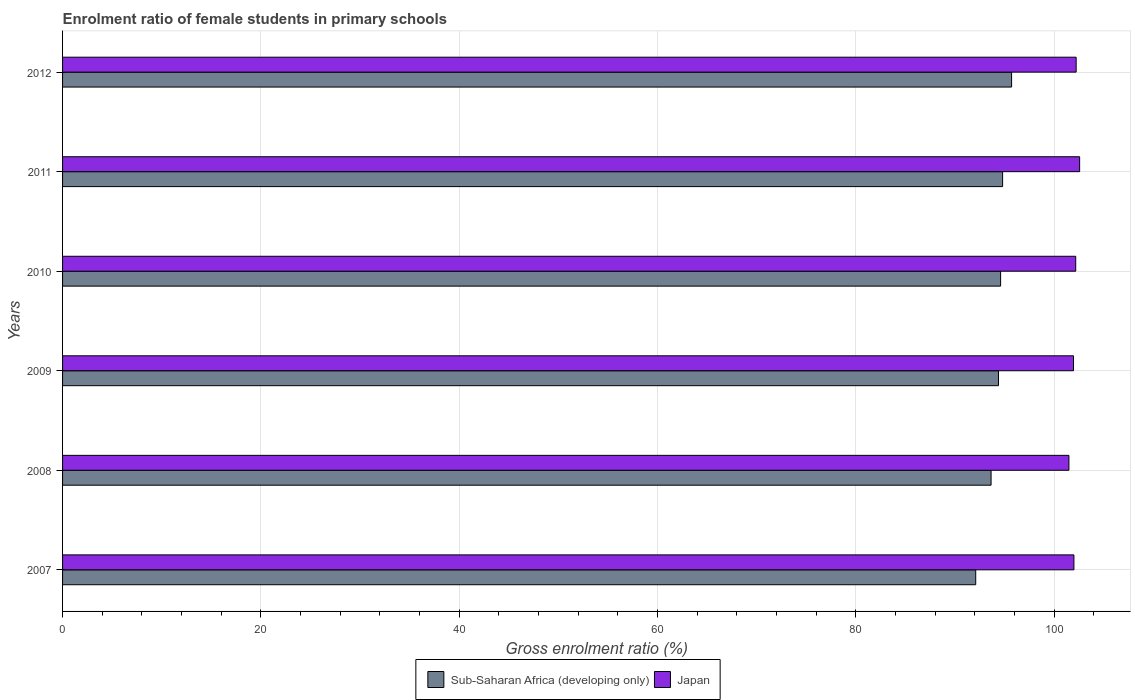How many different coloured bars are there?
Offer a very short reply. 2. How many groups of bars are there?
Keep it short and to the point. 6. How many bars are there on the 2nd tick from the top?
Keep it short and to the point. 2. What is the enrolment ratio of female students in primary schools in Japan in 2008?
Your answer should be compact. 101.48. Across all years, what is the maximum enrolment ratio of female students in primary schools in Japan?
Ensure brevity in your answer.  102.56. Across all years, what is the minimum enrolment ratio of female students in primary schools in Sub-Saharan Africa (developing only)?
Your response must be concise. 92.09. What is the total enrolment ratio of female students in primary schools in Japan in the graph?
Offer a very short reply. 612.36. What is the difference between the enrolment ratio of female students in primary schools in Sub-Saharan Africa (developing only) in 2008 and that in 2011?
Keep it short and to the point. -1.16. What is the difference between the enrolment ratio of female students in primary schools in Sub-Saharan Africa (developing only) in 2010 and the enrolment ratio of female students in primary schools in Japan in 2007?
Your response must be concise. -7.39. What is the average enrolment ratio of female students in primary schools in Japan per year?
Your answer should be very brief. 102.06. In the year 2009, what is the difference between the enrolment ratio of female students in primary schools in Sub-Saharan Africa (developing only) and enrolment ratio of female students in primary schools in Japan?
Your answer should be very brief. -7.56. What is the ratio of the enrolment ratio of female students in primary schools in Sub-Saharan Africa (developing only) in 2009 to that in 2012?
Your answer should be compact. 0.99. What is the difference between the highest and the second highest enrolment ratio of female students in primary schools in Sub-Saharan Africa (developing only)?
Make the answer very short. 0.91. What is the difference between the highest and the lowest enrolment ratio of female students in primary schools in Sub-Saharan Africa (developing only)?
Make the answer very short. 3.62. In how many years, is the enrolment ratio of female students in primary schools in Sub-Saharan Africa (developing only) greater than the average enrolment ratio of female students in primary schools in Sub-Saharan Africa (developing only) taken over all years?
Offer a very short reply. 4. Is the sum of the enrolment ratio of female students in primary schools in Japan in 2008 and 2012 greater than the maximum enrolment ratio of female students in primary schools in Sub-Saharan Africa (developing only) across all years?
Offer a very short reply. Yes. What does the 1st bar from the bottom in 2010 represents?
Give a very brief answer. Sub-Saharan Africa (developing only). How many bars are there?
Give a very brief answer. 12. Does the graph contain grids?
Your response must be concise. Yes. How many legend labels are there?
Offer a very short reply. 2. What is the title of the graph?
Your answer should be compact. Enrolment ratio of female students in primary schools. Does "Latvia" appear as one of the legend labels in the graph?
Keep it short and to the point. No. What is the label or title of the X-axis?
Offer a terse response. Gross enrolment ratio (%). What is the Gross enrolment ratio (%) in Sub-Saharan Africa (developing only) in 2007?
Your answer should be very brief. 92.09. What is the Gross enrolment ratio (%) of Japan in 2007?
Give a very brief answer. 101.99. What is the Gross enrolment ratio (%) of Sub-Saharan Africa (developing only) in 2008?
Provide a succinct answer. 93.63. What is the Gross enrolment ratio (%) in Japan in 2008?
Your response must be concise. 101.48. What is the Gross enrolment ratio (%) of Sub-Saharan Africa (developing only) in 2009?
Ensure brevity in your answer.  94.38. What is the Gross enrolment ratio (%) of Japan in 2009?
Offer a very short reply. 101.94. What is the Gross enrolment ratio (%) of Sub-Saharan Africa (developing only) in 2010?
Make the answer very short. 94.59. What is the Gross enrolment ratio (%) of Japan in 2010?
Give a very brief answer. 102.17. What is the Gross enrolment ratio (%) of Sub-Saharan Africa (developing only) in 2011?
Offer a very short reply. 94.8. What is the Gross enrolment ratio (%) in Japan in 2011?
Keep it short and to the point. 102.56. What is the Gross enrolment ratio (%) in Sub-Saharan Africa (developing only) in 2012?
Provide a succinct answer. 95.7. What is the Gross enrolment ratio (%) of Japan in 2012?
Give a very brief answer. 102.21. Across all years, what is the maximum Gross enrolment ratio (%) in Sub-Saharan Africa (developing only)?
Make the answer very short. 95.7. Across all years, what is the maximum Gross enrolment ratio (%) of Japan?
Your answer should be compact. 102.56. Across all years, what is the minimum Gross enrolment ratio (%) in Sub-Saharan Africa (developing only)?
Your answer should be compact. 92.09. Across all years, what is the minimum Gross enrolment ratio (%) in Japan?
Give a very brief answer. 101.48. What is the total Gross enrolment ratio (%) in Sub-Saharan Africa (developing only) in the graph?
Give a very brief answer. 565.19. What is the total Gross enrolment ratio (%) in Japan in the graph?
Offer a very short reply. 612.36. What is the difference between the Gross enrolment ratio (%) of Sub-Saharan Africa (developing only) in 2007 and that in 2008?
Your answer should be compact. -1.55. What is the difference between the Gross enrolment ratio (%) of Japan in 2007 and that in 2008?
Give a very brief answer. 0.5. What is the difference between the Gross enrolment ratio (%) of Sub-Saharan Africa (developing only) in 2007 and that in 2009?
Ensure brevity in your answer.  -2.29. What is the difference between the Gross enrolment ratio (%) in Japan in 2007 and that in 2009?
Make the answer very short. 0.04. What is the difference between the Gross enrolment ratio (%) in Sub-Saharan Africa (developing only) in 2007 and that in 2010?
Offer a terse response. -2.51. What is the difference between the Gross enrolment ratio (%) of Japan in 2007 and that in 2010?
Provide a succinct answer. -0.18. What is the difference between the Gross enrolment ratio (%) of Sub-Saharan Africa (developing only) in 2007 and that in 2011?
Your answer should be very brief. -2.71. What is the difference between the Gross enrolment ratio (%) in Japan in 2007 and that in 2011?
Offer a terse response. -0.58. What is the difference between the Gross enrolment ratio (%) in Sub-Saharan Africa (developing only) in 2007 and that in 2012?
Provide a succinct answer. -3.62. What is the difference between the Gross enrolment ratio (%) of Japan in 2007 and that in 2012?
Give a very brief answer. -0.23. What is the difference between the Gross enrolment ratio (%) in Sub-Saharan Africa (developing only) in 2008 and that in 2009?
Ensure brevity in your answer.  -0.75. What is the difference between the Gross enrolment ratio (%) in Japan in 2008 and that in 2009?
Ensure brevity in your answer.  -0.46. What is the difference between the Gross enrolment ratio (%) of Sub-Saharan Africa (developing only) in 2008 and that in 2010?
Keep it short and to the point. -0.96. What is the difference between the Gross enrolment ratio (%) of Japan in 2008 and that in 2010?
Provide a succinct answer. -0.69. What is the difference between the Gross enrolment ratio (%) of Sub-Saharan Africa (developing only) in 2008 and that in 2011?
Your answer should be compact. -1.16. What is the difference between the Gross enrolment ratio (%) of Japan in 2008 and that in 2011?
Give a very brief answer. -1.08. What is the difference between the Gross enrolment ratio (%) in Sub-Saharan Africa (developing only) in 2008 and that in 2012?
Your answer should be compact. -2.07. What is the difference between the Gross enrolment ratio (%) in Japan in 2008 and that in 2012?
Offer a very short reply. -0.73. What is the difference between the Gross enrolment ratio (%) of Sub-Saharan Africa (developing only) in 2009 and that in 2010?
Offer a very short reply. -0.21. What is the difference between the Gross enrolment ratio (%) of Japan in 2009 and that in 2010?
Ensure brevity in your answer.  -0.22. What is the difference between the Gross enrolment ratio (%) of Sub-Saharan Africa (developing only) in 2009 and that in 2011?
Your answer should be compact. -0.42. What is the difference between the Gross enrolment ratio (%) of Japan in 2009 and that in 2011?
Give a very brief answer. -0.62. What is the difference between the Gross enrolment ratio (%) in Sub-Saharan Africa (developing only) in 2009 and that in 2012?
Give a very brief answer. -1.32. What is the difference between the Gross enrolment ratio (%) in Japan in 2009 and that in 2012?
Offer a terse response. -0.27. What is the difference between the Gross enrolment ratio (%) in Sub-Saharan Africa (developing only) in 2010 and that in 2011?
Give a very brief answer. -0.2. What is the difference between the Gross enrolment ratio (%) of Japan in 2010 and that in 2011?
Keep it short and to the point. -0.4. What is the difference between the Gross enrolment ratio (%) in Sub-Saharan Africa (developing only) in 2010 and that in 2012?
Your response must be concise. -1.11. What is the difference between the Gross enrolment ratio (%) in Japan in 2010 and that in 2012?
Give a very brief answer. -0.04. What is the difference between the Gross enrolment ratio (%) of Sub-Saharan Africa (developing only) in 2011 and that in 2012?
Your answer should be very brief. -0.91. What is the difference between the Gross enrolment ratio (%) in Japan in 2011 and that in 2012?
Your answer should be compact. 0.35. What is the difference between the Gross enrolment ratio (%) in Sub-Saharan Africa (developing only) in 2007 and the Gross enrolment ratio (%) in Japan in 2008?
Give a very brief answer. -9.4. What is the difference between the Gross enrolment ratio (%) in Sub-Saharan Africa (developing only) in 2007 and the Gross enrolment ratio (%) in Japan in 2009?
Give a very brief answer. -9.86. What is the difference between the Gross enrolment ratio (%) in Sub-Saharan Africa (developing only) in 2007 and the Gross enrolment ratio (%) in Japan in 2010?
Give a very brief answer. -10.08. What is the difference between the Gross enrolment ratio (%) of Sub-Saharan Africa (developing only) in 2007 and the Gross enrolment ratio (%) of Japan in 2011?
Your answer should be very brief. -10.48. What is the difference between the Gross enrolment ratio (%) of Sub-Saharan Africa (developing only) in 2007 and the Gross enrolment ratio (%) of Japan in 2012?
Offer a terse response. -10.13. What is the difference between the Gross enrolment ratio (%) in Sub-Saharan Africa (developing only) in 2008 and the Gross enrolment ratio (%) in Japan in 2009?
Offer a very short reply. -8.31. What is the difference between the Gross enrolment ratio (%) in Sub-Saharan Africa (developing only) in 2008 and the Gross enrolment ratio (%) in Japan in 2010?
Make the answer very short. -8.54. What is the difference between the Gross enrolment ratio (%) in Sub-Saharan Africa (developing only) in 2008 and the Gross enrolment ratio (%) in Japan in 2011?
Offer a terse response. -8.93. What is the difference between the Gross enrolment ratio (%) in Sub-Saharan Africa (developing only) in 2008 and the Gross enrolment ratio (%) in Japan in 2012?
Offer a very short reply. -8.58. What is the difference between the Gross enrolment ratio (%) in Sub-Saharan Africa (developing only) in 2009 and the Gross enrolment ratio (%) in Japan in 2010?
Provide a short and direct response. -7.79. What is the difference between the Gross enrolment ratio (%) of Sub-Saharan Africa (developing only) in 2009 and the Gross enrolment ratio (%) of Japan in 2011?
Ensure brevity in your answer.  -8.18. What is the difference between the Gross enrolment ratio (%) of Sub-Saharan Africa (developing only) in 2009 and the Gross enrolment ratio (%) of Japan in 2012?
Provide a succinct answer. -7.83. What is the difference between the Gross enrolment ratio (%) of Sub-Saharan Africa (developing only) in 2010 and the Gross enrolment ratio (%) of Japan in 2011?
Keep it short and to the point. -7.97. What is the difference between the Gross enrolment ratio (%) of Sub-Saharan Africa (developing only) in 2010 and the Gross enrolment ratio (%) of Japan in 2012?
Make the answer very short. -7.62. What is the difference between the Gross enrolment ratio (%) of Sub-Saharan Africa (developing only) in 2011 and the Gross enrolment ratio (%) of Japan in 2012?
Keep it short and to the point. -7.42. What is the average Gross enrolment ratio (%) in Sub-Saharan Africa (developing only) per year?
Provide a succinct answer. 94.2. What is the average Gross enrolment ratio (%) in Japan per year?
Your response must be concise. 102.06. In the year 2007, what is the difference between the Gross enrolment ratio (%) in Sub-Saharan Africa (developing only) and Gross enrolment ratio (%) in Japan?
Keep it short and to the point. -9.9. In the year 2008, what is the difference between the Gross enrolment ratio (%) in Sub-Saharan Africa (developing only) and Gross enrolment ratio (%) in Japan?
Offer a very short reply. -7.85. In the year 2009, what is the difference between the Gross enrolment ratio (%) in Sub-Saharan Africa (developing only) and Gross enrolment ratio (%) in Japan?
Your answer should be very brief. -7.56. In the year 2010, what is the difference between the Gross enrolment ratio (%) in Sub-Saharan Africa (developing only) and Gross enrolment ratio (%) in Japan?
Give a very brief answer. -7.57. In the year 2011, what is the difference between the Gross enrolment ratio (%) in Sub-Saharan Africa (developing only) and Gross enrolment ratio (%) in Japan?
Provide a succinct answer. -7.77. In the year 2012, what is the difference between the Gross enrolment ratio (%) in Sub-Saharan Africa (developing only) and Gross enrolment ratio (%) in Japan?
Provide a short and direct response. -6.51. What is the ratio of the Gross enrolment ratio (%) in Sub-Saharan Africa (developing only) in 2007 to that in 2008?
Your response must be concise. 0.98. What is the ratio of the Gross enrolment ratio (%) in Japan in 2007 to that in 2008?
Provide a succinct answer. 1. What is the ratio of the Gross enrolment ratio (%) of Sub-Saharan Africa (developing only) in 2007 to that in 2009?
Provide a short and direct response. 0.98. What is the ratio of the Gross enrolment ratio (%) in Sub-Saharan Africa (developing only) in 2007 to that in 2010?
Your response must be concise. 0.97. What is the ratio of the Gross enrolment ratio (%) in Sub-Saharan Africa (developing only) in 2007 to that in 2011?
Offer a very short reply. 0.97. What is the ratio of the Gross enrolment ratio (%) of Japan in 2007 to that in 2011?
Provide a short and direct response. 0.99. What is the ratio of the Gross enrolment ratio (%) of Sub-Saharan Africa (developing only) in 2007 to that in 2012?
Offer a very short reply. 0.96. What is the ratio of the Gross enrolment ratio (%) in Japan in 2008 to that in 2009?
Give a very brief answer. 1. What is the ratio of the Gross enrolment ratio (%) of Sub-Saharan Africa (developing only) in 2008 to that in 2010?
Offer a very short reply. 0.99. What is the ratio of the Gross enrolment ratio (%) in Sub-Saharan Africa (developing only) in 2008 to that in 2012?
Your response must be concise. 0.98. What is the ratio of the Gross enrolment ratio (%) in Japan in 2008 to that in 2012?
Make the answer very short. 0.99. What is the ratio of the Gross enrolment ratio (%) in Sub-Saharan Africa (developing only) in 2009 to that in 2010?
Make the answer very short. 1. What is the ratio of the Gross enrolment ratio (%) of Sub-Saharan Africa (developing only) in 2009 to that in 2012?
Offer a very short reply. 0.99. What is the ratio of the Gross enrolment ratio (%) of Japan in 2009 to that in 2012?
Ensure brevity in your answer.  1. What is the ratio of the Gross enrolment ratio (%) of Sub-Saharan Africa (developing only) in 2010 to that in 2012?
Ensure brevity in your answer.  0.99. What is the ratio of the Gross enrolment ratio (%) in Sub-Saharan Africa (developing only) in 2011 to that in 2012?
Make the answer very short. 0.99. What is the difference between the highest and the second highest Gross enrolment ratio (%) of Sub-Saharan Africa (developing only)?
Ensure brevity in your answer.  0.91. What is the difference between the highest and the second highest Gross enrolment ratio (%) in Japan?
Provide a short and direct response. 0.35. What is the difference between the highest and the lowest Gross enrolment ratio (%) of Sub-Saharan Africa (developing only)?
Offer a very short reply. 3.62. What is the difference between the highest and the lowest Gross enrolment ratio (%) in Japan?
Offer a very short reply. 1.08. 